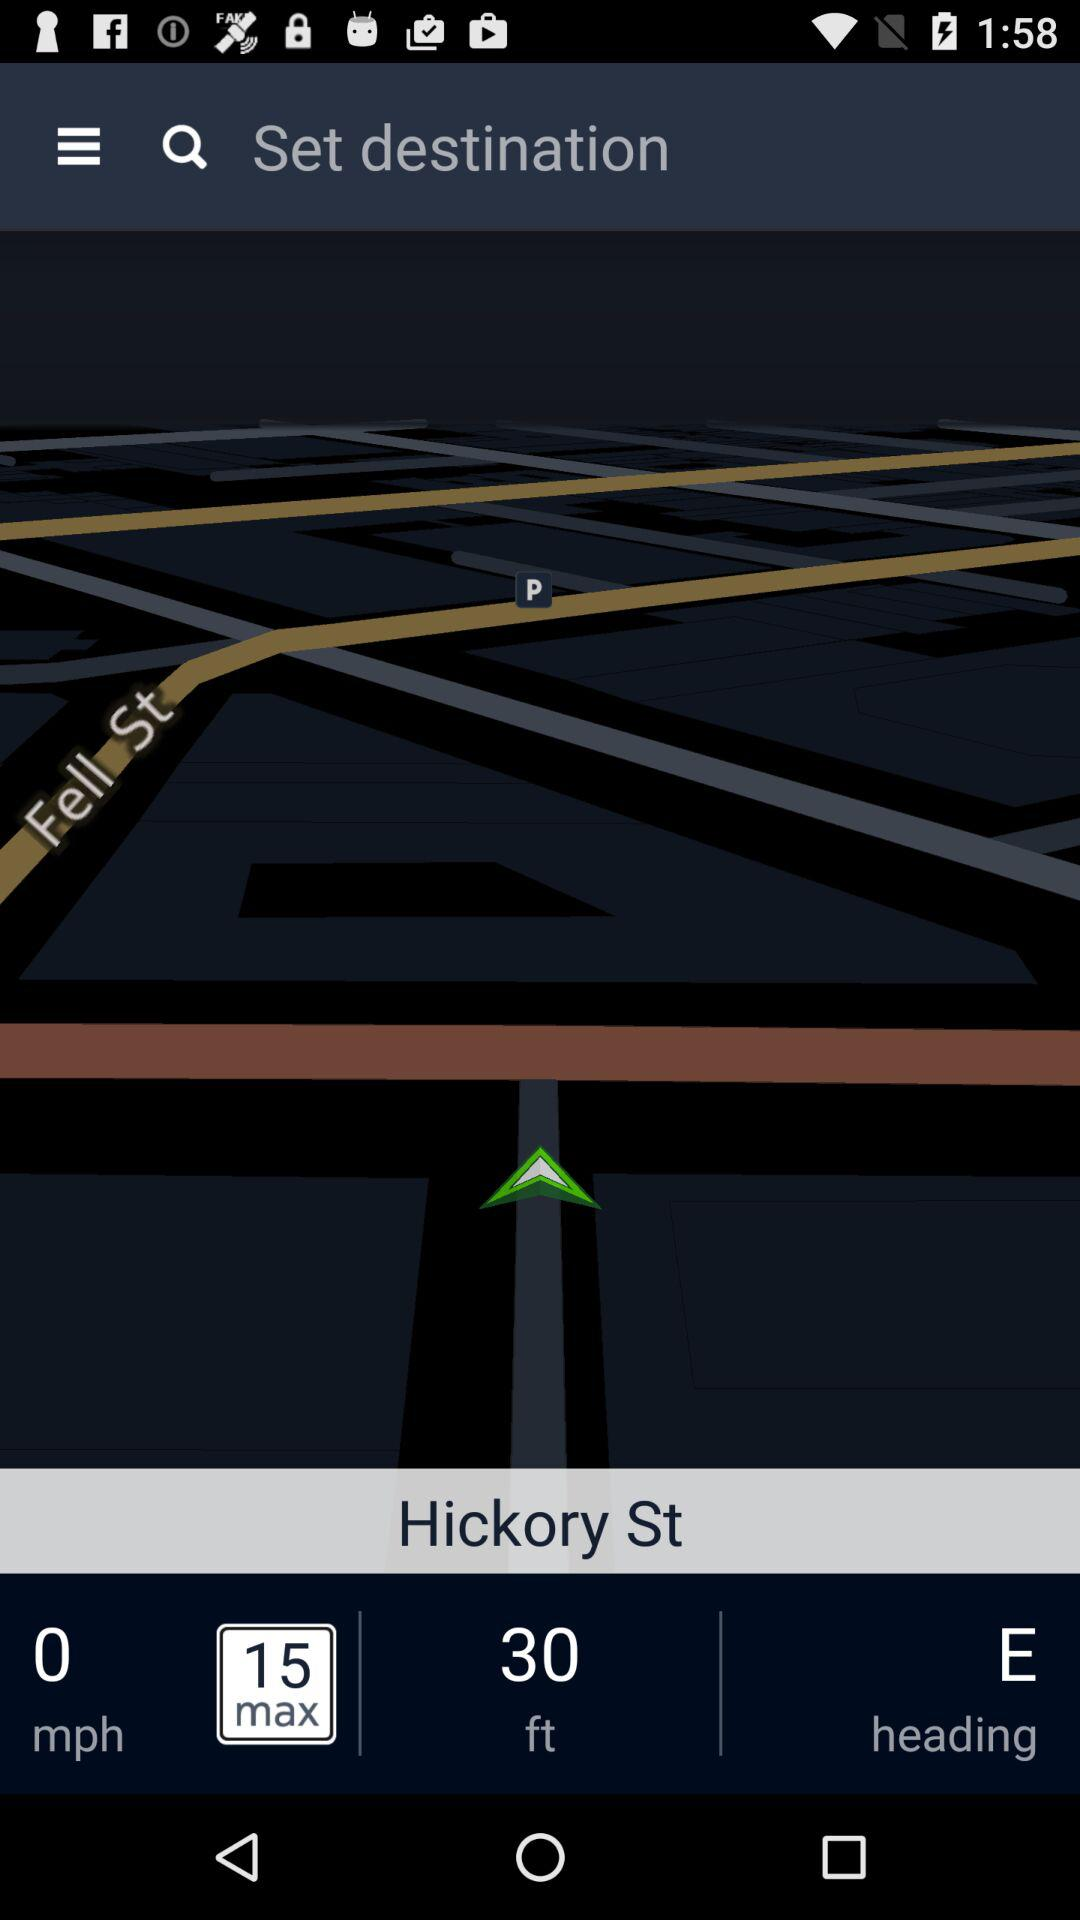In what direction is Hickory St heading? Hickory St is heading towards the east direction. 